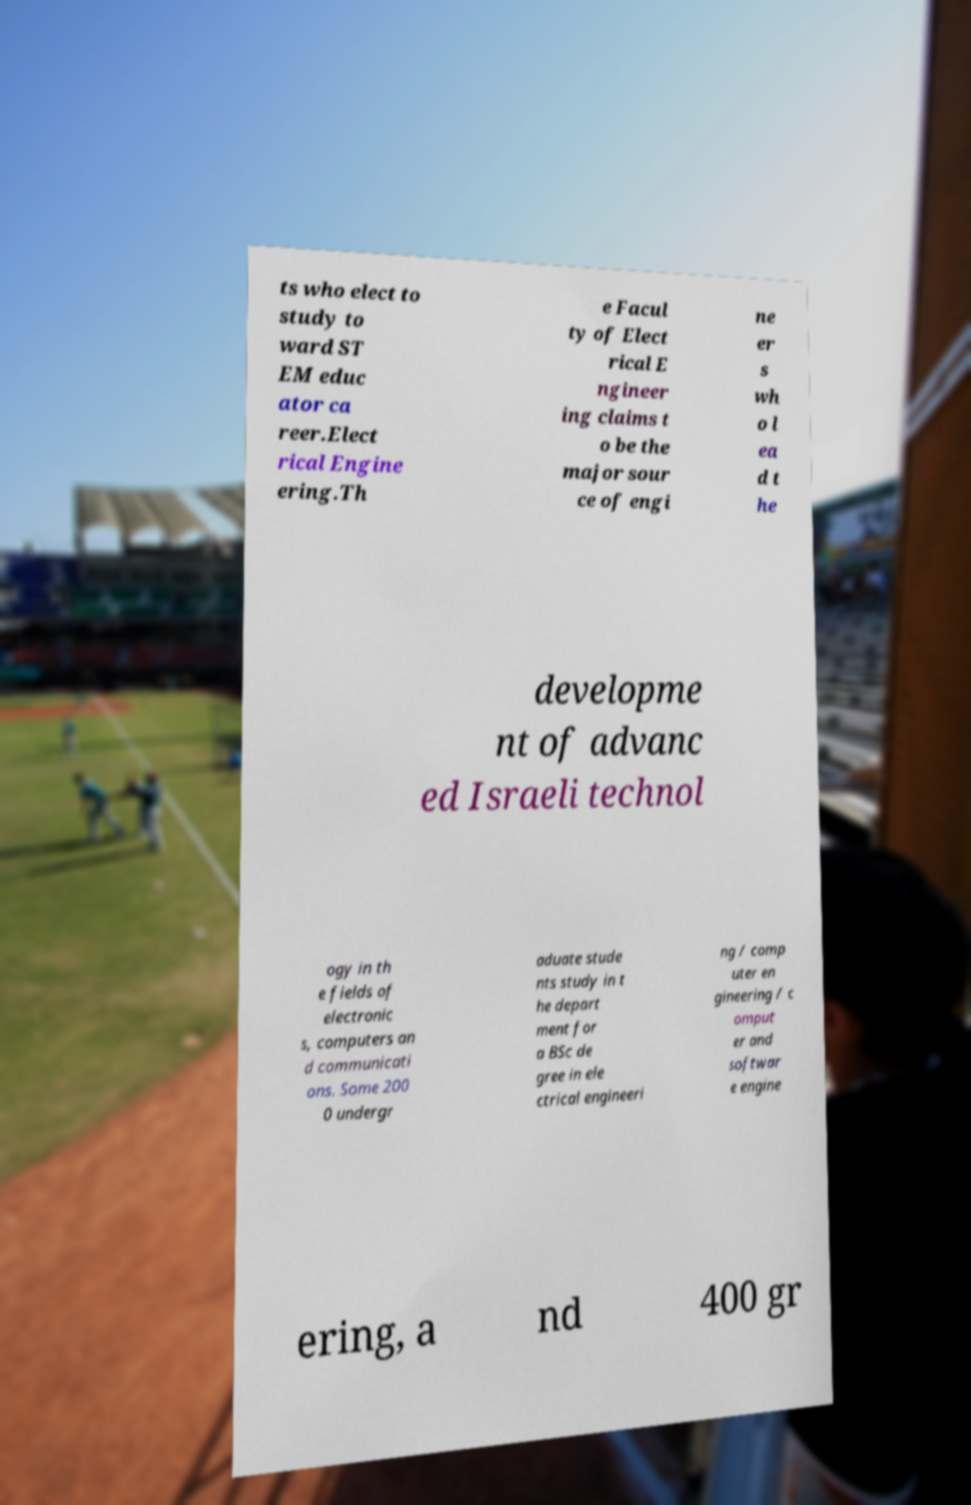Please identify and transcribe the text found in this image. ts who elect to study to ward ST EM educ ator ca reer.Elect rical Engine ering.Th e Facul ty of Elect rical E ngineer ing claims t o be the major sour ce of engi ne er s wh o l ea d t he developme nt of advanc ed Israeli technol ogy in th e fields of electronic s, computers an d communicati ons. Some 200 0 undergr aduate stude nts study in t he depart ment for a BSc de gree in ele ctrical engineeri ng / comp uter en gineering / c omput er and softwar e engine ering, a nd 400 gr 